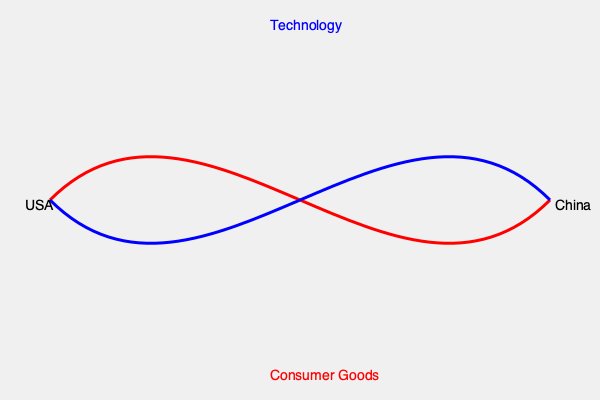Based on the global trade flow map, what critical insight can be drawn about the economic relationship between the USA and China, and how might this impact international diplomacy? To answer this question, we need to analyze the trade flows depicted in the map:

1. Direction of arrows:
   - Blue arrow: USA to China
   - Red arrow: China to USA

2. Labels on arrows:
   - Blue arrow (USA to China): Technology
   - Red arrow (China to USA): Consumer Goods

3. Interpretation:
   a) The USA is exporting technology to China
   b) China is exporting consumer goods to the USA

4. Economic implications:
   - This suggests a complementary trade relationship
   - The USA specializes in high-tech products
   - China focuses on manufacturing consumer goods

5. Impact on international diplomacy:
   - Economic interdependence between the two nations
   - Potential leverage in trade negotiations
   - Complexity in addressing trade imbalances
   - Technological transfer concerns

6. Critical insight:
   The trade relationship demonstrates mutual dependence, with the USA providing advanced technology and China supplying manufactured goods. This interdependence complicates diplomatic relations, as any disruption to trade could have significant economic consequences for both nations.
Answer: Economic interdependence through technology-consumer goods exchange complicates US-China diplomacy. 